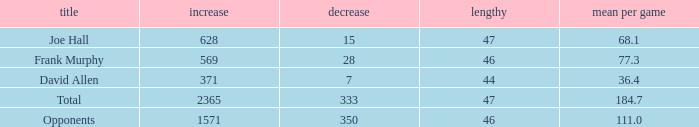Which Avg/G is the lowest one that has a Long smaller than 47, and a Name of frank murphy, and a Gain smaller than 569? None. 